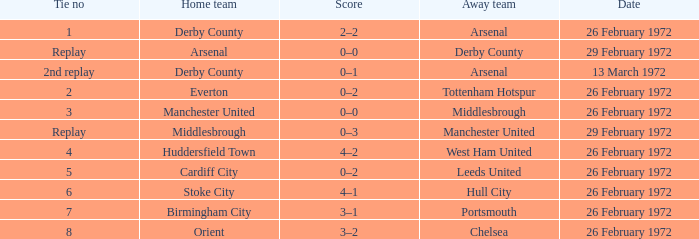I'm looking to parse the entire table for insights. Could you assist me with that? {'header': ['Tie no', 'Home team', 'Score', 'Away team', 'Date'], 'rows': [['1', 'Derby County', '2–2', 'Arsenal', '26 February 1972'], ['Replay', 'Arsenal', '0–0', 'Derby County', '29 February 1972'], ['2nd replay', 'Derby County', '0–1', 'Arsenal', '13 March 1972'], ['2', 'Everton', '0–2', 'Tottenham Hotspur', '26 February 1972'], ['3', 'Manchester United', '0–0', 'Middlesbrough', '26 February 1972'], ['Replay', 'Middlesbrough', '0–3', 'Manchester United', '29 February 1972'], ['4', 'Huddersfield Town', '4–2', 'West Ham United', '26 February 1972'], ['5', 'Cardiff City', '0–2', 'Leeds United', '26 February 1972'], ['6', 'Stoke City', '4–1', 'Hull City', '26 February 1972'], ['7', 'Birmingham City', '3–1', 'Portsmouth', '26 February 1972'], ['8', 'Orient', '3–2', 'Chelsea', '26 February 1972']]} Which Tie is from everton? 2.0. 